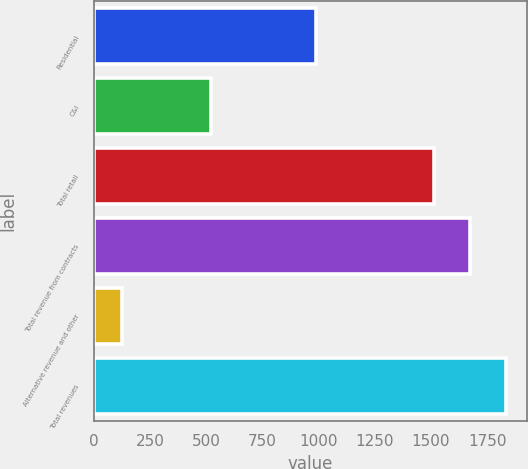Convert chart. <chart><loc_0><loc_0><loc_500><loc_500><bar_chart><fcel>Residential<fcel>C&I<fcel>Total retail<fcel>Total revenue from contracts<fcel>Alternative revenue and other<fcel>Total revenues<nl><fcel>988<fcel>524<fcel>1512<fcel>1673.2<fcel>127<fcel>1834.4<nl></chart> 